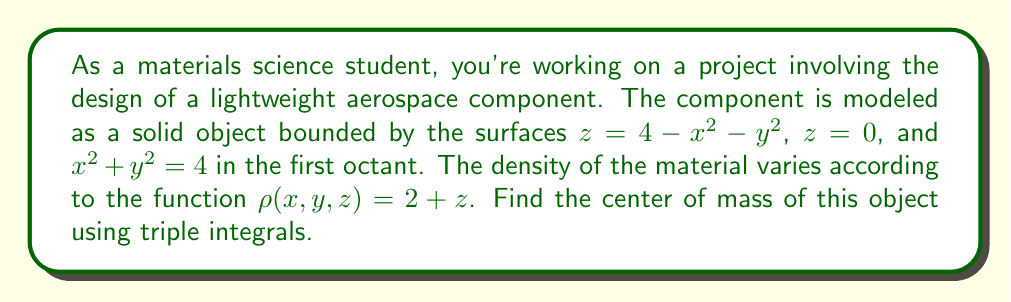Teach me how to tackle this problem. To find the center of mass of a 3D object, we need to calculate the following:

1. The mass of the object (M)
2. The moments about the yz-plane (M_x), xz-plane (M_y), and xy-plane (M_z)

Then, the center of mass coordinates (x_cm, y_cm, z_cm) are given by:

$$ x_{cm} = \frac{M_x}{M}, \quad y_{cm} = \frac{M_y}{M}, \quad z_{cm} = \frac{M_z}{M} $$

Let's set up the triple integrals for each calculation:

1. Mass of the object:
$$ M = \iiint_V \rho(x,y,z) \, dV $$

2. Moments:
$$ M_x = \iiint_V x\rho(x,y,z) \, dV $$
$$ M_y = \iiint_V y\rho(x,y,z) \, dV $$
$$ M_z = \iiint_V z\rho(x,y,z) \, dV $$

Given the boundaries of the object, we'll use cylindrical coordinates:
$x = r\cos\theta$, $y = r\sin\theta$, $z = z$

The limits of integration are:
$0 \leq r \leq 2$, $0 \leq \theta \leq \frac{\pi}{2}$, $0 \leq z \leq 4 - r^2$

Now, let's evaluate each integral:

1. Mass:
$$ M = \int_0^{\frac{\pi}{2}} \int_0^2 \int_0^{4-r^2} (2+z)r \, dz \, dr \, d\theta $$
$$ = \frac{\pi}{2} \int_0^2 \left[ 2r(4-r^2) + \frac{r}{2}(4-r^2)^2 \right] dr $$
$$ = \frac{\pi}{2} \left[ 16 - \frac{32}{3} + \frac{128}{15} \right] = \frac{64\pi}{15} $$

2. M_x:
$$ M_x = \int_0^{\frac{\pi}{2}} \int_0^2 \int_0^{4-r^2} (2+z)r^2\cos\theta \, dz \, dr \, d\theta $$
$$ = \int_0^2 \left[ 2r^2(4-r^2) + \frac{r^2}{2}(4-r^2)^2 \right] dr \int_0^{\frac{\pi}{2}} \cos\theta \, d\theta $$
$$ = \left[ \frac{32}{3} - \frac{32}{5} + \frac{256}{35} \right] = \frac{128}{35} $$

3. M_y:
Due to symmetry, M_y = M_x = $\frac{128}{35}$

4. M_z:
$$ M_z = \int_0^{\frac{\pi}{2}} \int_0^2 \int_0^{4-r^2} (2+z)rz \, dz \, dr \, d\theta $$
$$ = \frac{\pi}{2} \int_0^2 \left[ r(4-r^2)^2 + \frac{r}{3}(4-r^2)^3 \right] dr $$
$$ = \frac{\pi}{2} \left[ \frac{128}{15} - \frac{256}{35} + \frac{256}{63} \right] = \frac{256\pi}{105} $$

Now, we can calculate the center of mass coordinates:

$$ x_{cm} = y_{cm} = \frac{M_x}{M} = \frac{128/35}{64\pi/15} = \frac{30}{\pi\sqrt{35}} $$
$$ z_{cm} = \frac{M_z}{M} = \frac{256\pi/105}{64\pi/15} = \frac{4}{7} $$
Answer: The center of mass of the object is located at $\left(\frac{30}{\pi\sqrt{35}}, \frac{30}{\pi\sqrt{35}}, \frac{4}{7}\right)$. 